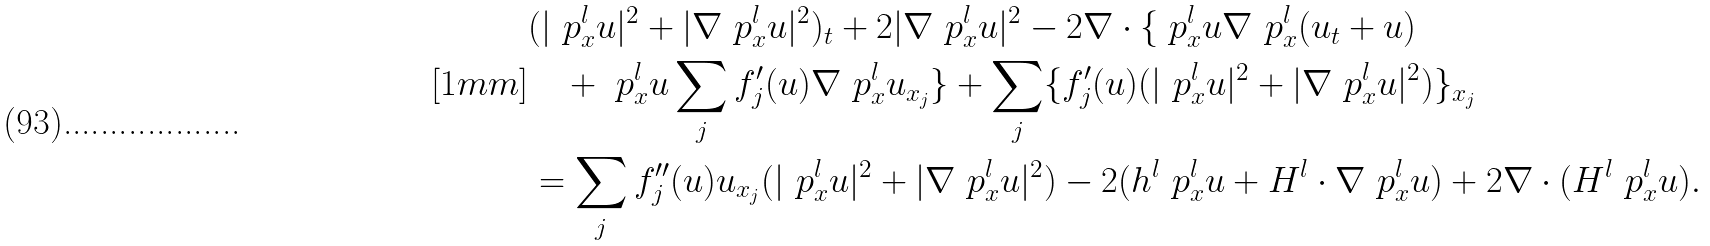Convert formula to latex. <formula><loc_0><loc_0><loc_500><loc_500>& ( | \ p _ { x } ^ { l } u | ^ { 2 } + | \nabla \ p _ { x } ^ { l } u | ^ { 2 } ) _ { t } + 2 | \nabla \ p _ { x } ^ { l } u | ^ { 2 } - 2 \nabla \cdot \{ \ p _ { x } ^ { l } u \nabla \ p _ { x } ^ { l } ( u _ { t } + u ) \\ [ 1 m m ] & \quad + \ p _ { x } ^ { l } u \sum _ { j } f _ { j } ^ { \prime } ( u ) \nabla \ p _ { x } ^ { l } u _ { x _ { j } } \} + \sum _ { j } \{ f _ { j } ^ { \prime } ( u ) ( | \ p _ { x } ^ { l } u | ^ { 2 } + | \nabla \ p _ { x } ^ { l } u | ^ { 2 } ) \} _ { x _ { j } } \\ & = \sum _ { j } f _ { j } ^ { \prime \prime } ( u ) u _ { x _ { j } } ( | \ p _ { x } ^ { l } u | ^ { 2 } + | \nabla \ p _ { x } ^ { l } u | ^ { 2 } ) - 2 ( h ^ { l } \ p _ { x } ^ { l } u + H ^ { l } \cdot \nabla \ p _ { x } ^ { l } u ) + 2 \nabla \cdot ( H ^ { l } \ p _ { x } ^ { l } u ) .</formula> 